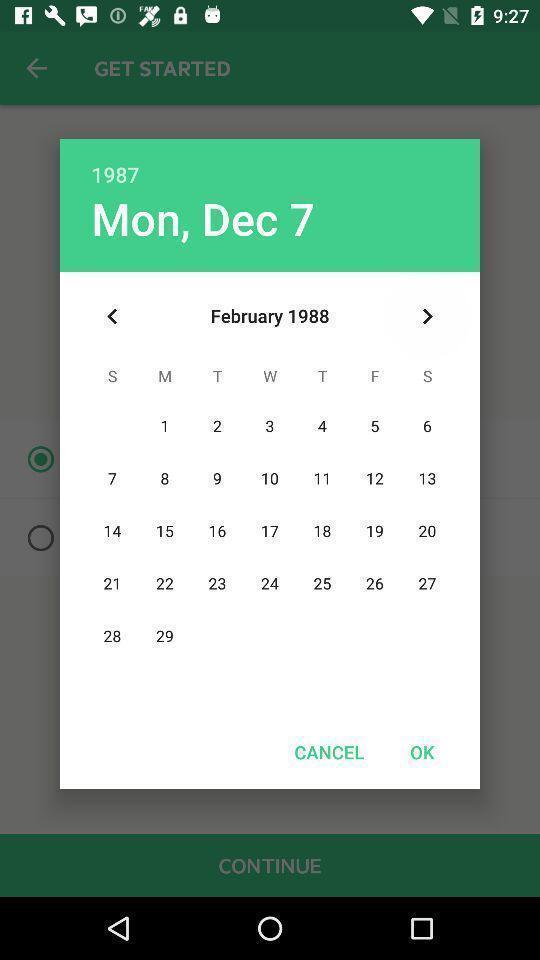Summarize the information in this screenshot. Popup of a calendar. 